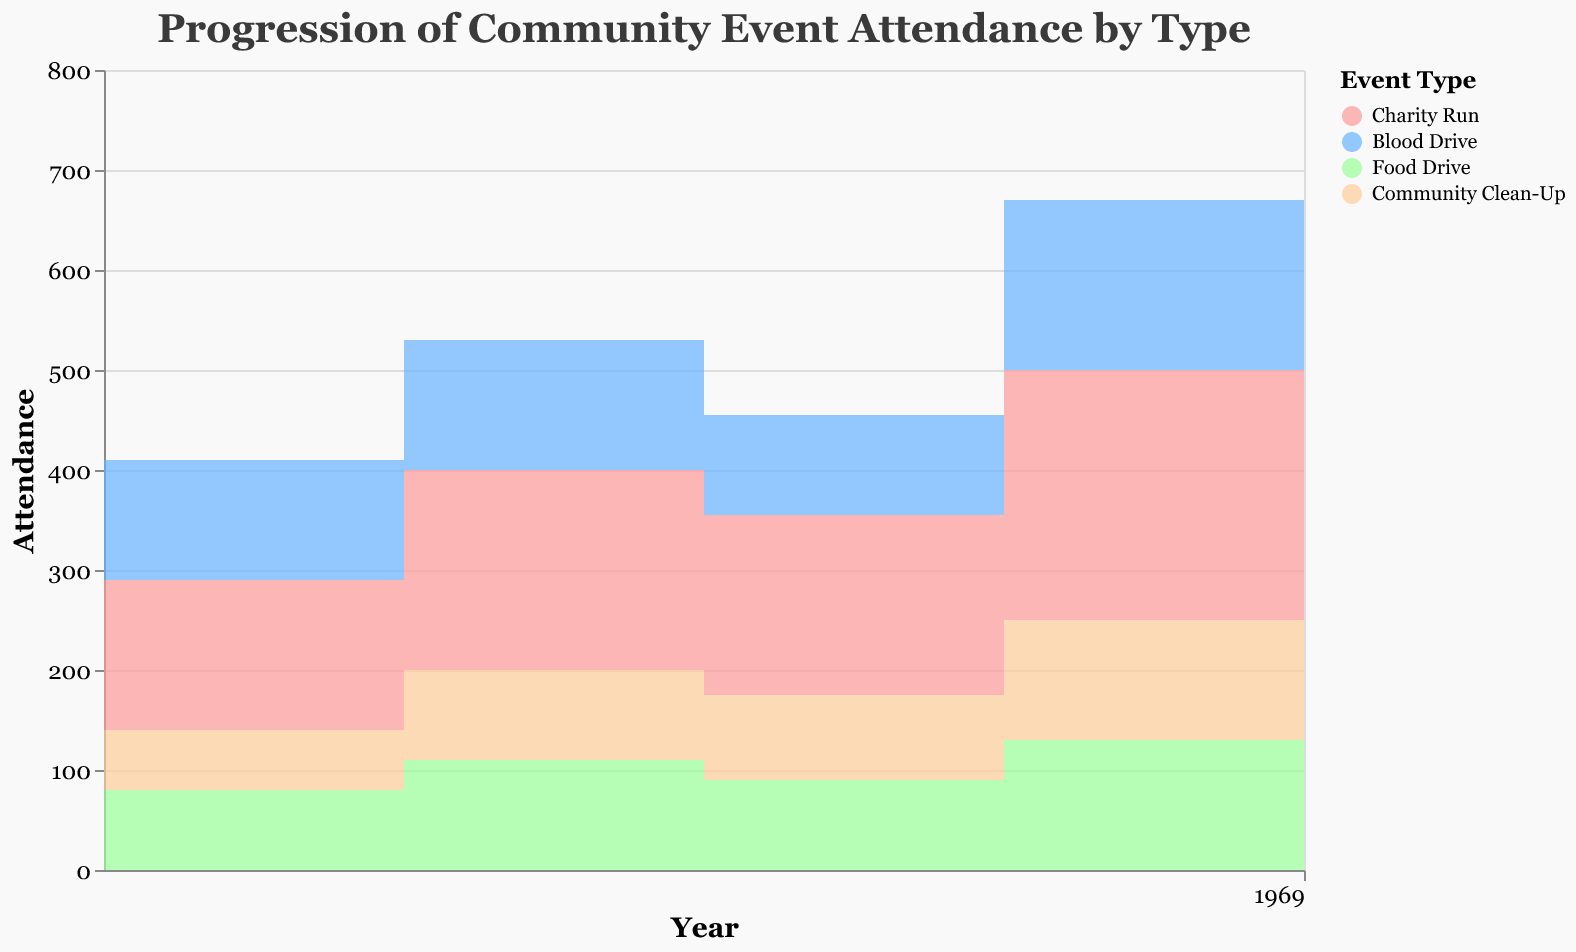What is the title of the chart? The title of the chart appears at the top and reads, "Progression of Community Event Attendance by Type".
Answer: Progression of Community Event Attendance by Type Which event type had the highest attendance in 2022? By looking at the colored segments in the year 2022 and their heights on the y-axis, the "Charity Run" segment is the highest.
Answer: Charity Run What is the overall trend for Charity Run attendance from 2018 to 2022? Observing the change in the height of the "Charity Run" segment from 2018 to 2022, it is clear that it increases over time, indicating a growing trend.
Answer: Increasing How does the attendance of the Blood Drive in 2021 compare to that in 2020? The height of the "Blood Drive" segment in 2021 is higher than in 2020, indicating that attendance increased from 100 to 170.
Answer: Increased by 70 Which event type showed the most consistent growth between 2018 and 2022? Examining the segments, "Community Clean-Up" steadily rises year-on-year without any decreases, showing consistent growth.
Answer: Community Clean-Up What was the attendance for Food Drive in 2019? By locating the "Food Drive" segment for the year 2019 on the x-axis, the height of the segment determines that the attendance was 110.
Answer: 110 Between 2018 and 2022, how much did attendance for Community Clean-Up increase? Subtracting the attendance in 2018 (60) from attendance in 2022 (150) for "Community Clean-Up" gives the increase. 150 - 60 = 90
Answer: 90 How do the trends for Blood Drive and Food Drive compare from 2018 to 2022? The "Blood Drive" shows fluctuations with a decrease in 2020 followed by an increase, while the "Food Drive" shows a steady increase overall.
Answer: Different trends; Blood Drive is fluctuating, Food Drive is steadily increasing What was the combined attendance for all events in 2018? Summing the attendance for all event types in 2018: 150 (Charity Run) + 120 (Blood Drive) + 80 (Food Drive) + 60 (Community Clean-Up). Total = 410
Answer: 410 